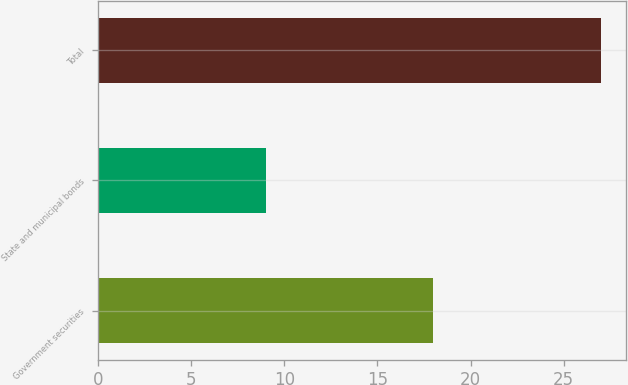Convert chart to OTSL. <chart><loc_0><loc_0><loc_500><loc_500><bar_chart><fcel>Government securities<fcel>State and municipal bonds<fcel>Total<nl><fcel>18<fcel>9<fcel>27<nl></chart> 